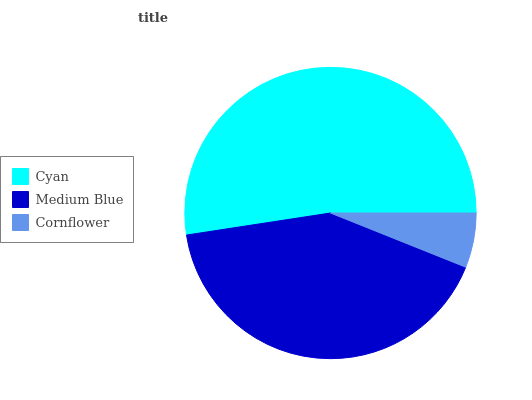Is Cornflower the minimum?
Answer yes or no. Yes. Is Cyan the maximum?
Answer yes or no. Yes. Is Medium Blue the minimum?
Answer yes or no. No. Is Medium Blue the maximum?
Answer yes or no. No. Is Cyan greater than Medium Blue?
Answer yes or no. Yes. Is Medium Blue less than Cyan?
Answer yes or no. Yes. Is Medium Blue greater than Cyan?
Answer yes or no. No. Is Cyan less than Medium Blue?
Answer yes or no. No. Is Medium Blue the high median?
Answer yes or no. Yes. Is Medium Blue the low median?
Answer yes or no. Yes. Is Cyan the high median?
Answer yes or no. No. Is Cyan the low median?
Answer yes or no. No. 